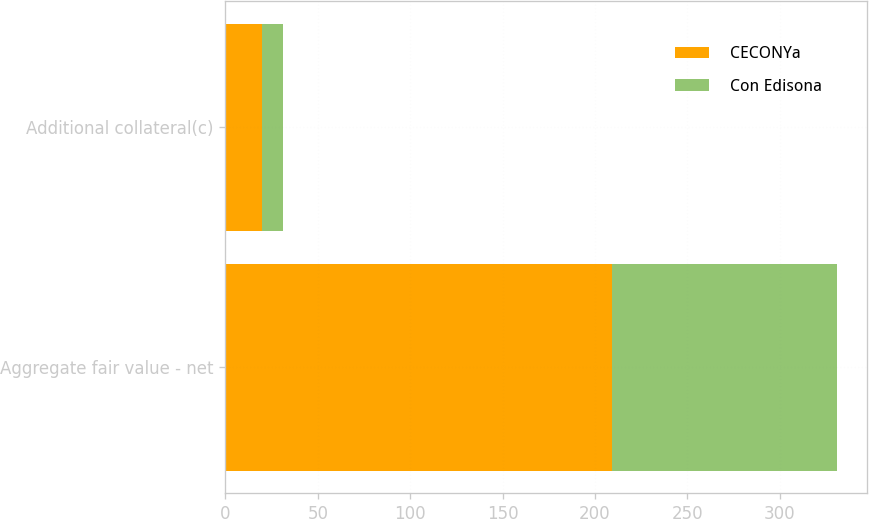Convert chart. <chart><loc_0><loc_0><loc_500><loc_500><stacked_bar_chart><ecel><fcel>Aggregate fair value - net<fcel>Additional collateral(c)<nl><fcel>CECONYa<fcel>209<fcel>20<nl><fcel>Con Edisona<fcel>122<fcel>11<nl></chart> 